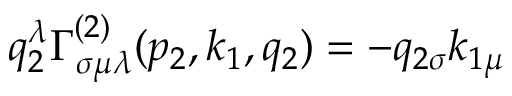<formula> <loc_0><loc_0><loc_500><loc_500>q _ { 2 } ^ { \lambda } \Gamma _ { \sigma \mu \lambda } ^ { ( 2 ) } ( p _ { 2 } , k _ { 1 } , q _ { 2 } ) = - q _ { 2 \sigma } k _ { 1 \mu }</formula> 